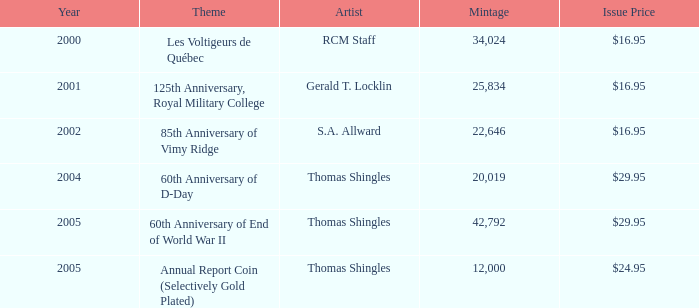When was the s.a. allward's theme with a release price of $16.95 launched? 2002.0. 